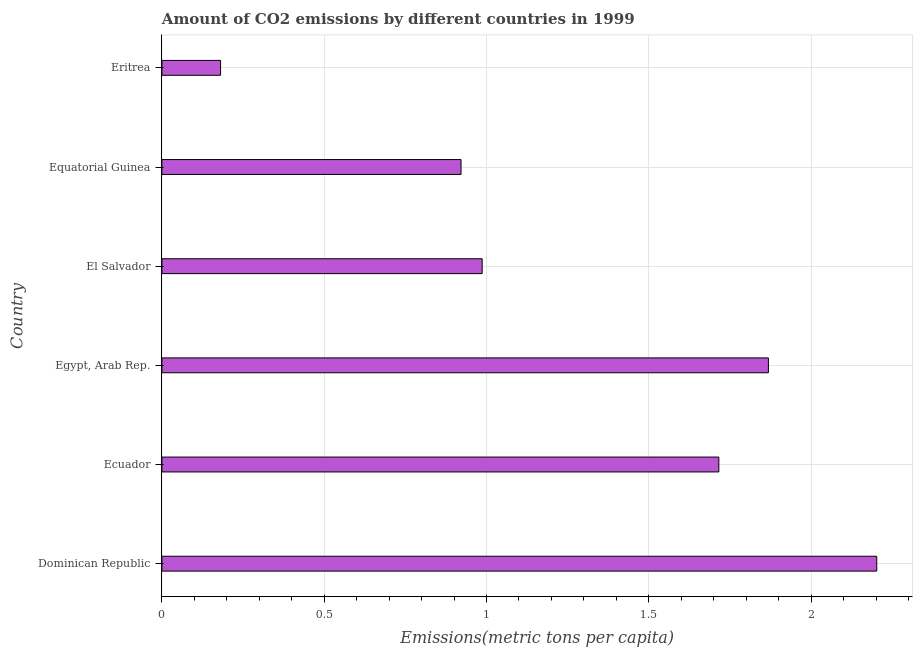Does the graph contain grids?
Ensure brevity in your answer.  Yes. What is the title of the graph?
Provide a short and direct response. Amount of CO2 emissions by different countries in 1999. What is the label or title of the X-axis?
Keep it short and to the point. Emissions(metric tons per capita). What is the label or title of the Y-axis?
Offer a terse response. Country. What is the amount of co2 emissions in Dominican Republic?
Your answer should be compact. 2.2. Across all countries, what is the maximum amount of co2 emissions?
Your answer should be compact. 2.2. Across all countries, what is the minimum amount of co2 emissions?
Keep it short and to the point. 0.18. In which country was the amount of co2 emissions maximum?
Your answer should be compact. Dominican Republic. In which country was the amount of co2 emissions minimum?
Your answer should be compact. Eritrea. What is the sum of the amount of co2 emissions?
Your response must be concise. 7.88. What is the difference between the amount of co2 emissions in Dominican Republic and Egypt, Arab Rep.?
Provide a short and direct response. 0.33. What is the average amount of co2 emissions per country?
Your response must be concise. 1.31. What is the median amount of co2 emissions?
Your response must be concise. 1.35. In how many countries, is the amount of co2 emissions greater than 0.1 metric tons per capita?
Offer a very short reply. 6. What is the ratio of the amount of co2 emissions in Dominican Republic to that in Eritrea?
Give a very brief answer. 12.19. Is the difference between the amount of co2 emissions in Dominican Republic and Eritrea greater than the difference between any two countries?
Provide a succinct answer. Yes. What is the difference between the highest and the second highest amount of co2 emissions?
Your answer should be compact. 0.33. What is the difference between the highest and the lowest amount of co2 emissions?
Offer a very short reply. 2.02. How many bars are there?
Ensure brevity in your answer.  6. How many countries are there in the graph?
Offer a terse response. 6. Are the values on the major ticks of X-axis written in scientific E-notation?
Provide a short and direct response. No. What is the Emissions(metric tons per capita) of Dominican Republic?
Give a very brief answer. 2.2. What is the Emissions(metric tons per capita) in Ecuador?
Make the answer very short. 1.72. What is the Emissions(metric tons per capita) in Egypt, Arab Rep.?
Ensure brevity in your answer.  1.87. What is the Emissions(metric tons per capita) in El Salvador?
Your response must be concise. 0.99. What is the Emissions(metric tons per capita) in Equatorial Guinea?
Ensure brevity in your answer.  0.92. What is the Emissions(metric tons per capita) of Eritrea?
Keep it short and to the point. 0.18. What is the difference between the Emissions(metric tons per capita) in Dominican Republic and Ecuador?
Ensure brevity in your answer.  0.49. What is the difference between the Emissions(metric tons per capita) in Dominican Republic and Egypt, Arab Rep.?
Offer a very short reply. 0.33. What is the difference between the Emissions(metric tons per capita) in Dominican Republic and El Salvador?
Your answer should be compact. 1.22. What is the difference between the Emissions(metric tons per capita) in Dominican Republic and Equatorial Guinea?
Your answer should be compact. 1.28. What is the difference between the Emissions(metric tons per capita) in Dominican Republic and Eritrea?
Make the answer very short. 2.02. What is the difference between the Emissions(metric tons per capita) in Ecuador and Egypt, Arab Rep.?
Make the answer very short. -0.15. What is the difference between the Emissions(metric tons per capita) in Ecuador and El Salvador?
Your answer should be very brief. 0.73. What is the difference between the Emissions(metric tons per capita) in Ecuador and Equatorial Guinea?
Provide a short and direct response. 0.79. What is the difference between the Emissions(metric tons per capita) in Ecuador and Eritrea?
Offer a very short reply. 1.53. What is the difference between the Emissions(metric tons per capita) in Egypt, Arab Rep. and El Salvador?
Give a very brief answer. 0.88. What is the difference between the Emissions(metric tons per capita) in Egypt, Arab Rep. and Equatorial Guinea?
Provide a succinct answer. 0.95. What is the difference between the Emissions(metric tons per capita) in Egypt, Arab Rep. and Eritrea?
Ensure brevity in your answer.  1.69. What is the difference between the Emissions(metric tons per capita) in El Salvador and Equatorial Guinea?
Your answer should be very brief. 0.07. What is the difference between the Emissions(metric tons per capita) in El Salvador and Eritrea?
Ensure brevity in your answer.  0.81. What is the difference between the Emissions(metric tons per capita) in Equatorial Guinea and Eritrea?
Ensure brevity in your answer.  0.74. What is the ratio of the Emissions(metric tons per capita) in Dominican Republic to that in Ecuador?
Your answer should be very brief. 1.28. What is the ratio of the Emissions(metric tons per capita) in Dominican Republic to that in Egypt, Arab Rep.?
Offer a very short reply. 1.18. What is the ratio of the Emissions(metric tons per capita) in Dominican Republic to that in El Salvador?
Make the answer very short. 2.23. What is the ratio of the Emissions(metric tons per capita) in Dominican Republic to that in Equatorial Guinea?
Give a very brief answer. 2.39. What is the ratio of the Emissions(metric tons per capita) in Dominican Republic to that in Eritrea?
Provide a short and direct response. 12.19. What is the ratio of the Emissions(metric tons per capita) in Ecuador to that in Egypt, Arab Rep.?
Offer a very short reply. 0.92. What is the ratio of the Emissions(metric tons per capita) in Ecuador to that in El Salvador?
Keep it short and to the point. 1.74. What is the ratio of the Emissions(metric tons per capita) in Ecuador to that in Equatorial Guinea?
Offer a terse response. 1.86. What is the ratio of the Emissions(metric tons per capita) in Ecuador to that in Eritrea?
Keep it short and to the point. 9.49. What is the ratio of the Emissions(metric tons per capita) in Egypt, Arab Rep. to that in El Salvador?
Make the answer very short. 1.89. What is the ratio of the Emissions(metric tons per capita) in Egypt, Arab Rep. to that in Equatorial Guinea?
Keep it short and to the point. 2.03. What is the ratio of the Emissions(metric tons per capita) in Egypt, Arab Rep. to that in Eritrea?
Your answer should be compact. 10.34. What is the ratio of the Emissions(metric tons per capita) in El Salvador to that in Equatorial Guinea?
Offer a terse response. 1.07. What is the ratio of the Emissions(metric tons per capita) in El Salvador to that in Eritrea?
Offer a terse response. 5.46. What is the ratio of the Emissions(metric tons per capita) in Equatorial Guinea to that in Eritrea?
Your answer should be compact. 5.1. 